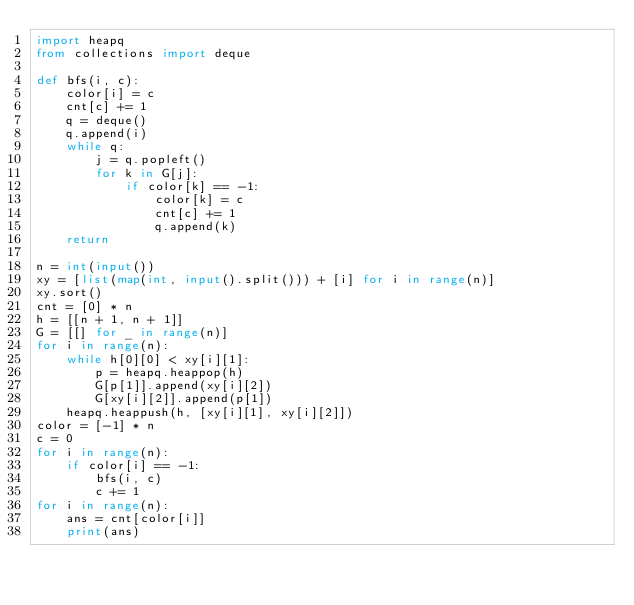Convert code to text. <code><loc_0><loc_0><loc_500><loc_500><_Python_>import heapq
from collections import deque

def bfs(i, c):
    color[i] = c
    cnt[c] += 1
    q = deque()
    q.append(i)
    while q:
        j = q.popleft()
        for k in G[j]:
            if color[k] == -1:
                color[k] = c
                cnt[c] += 1
                q.append(k)
    return

n = int(input())
xy = [list(map(int, input().split())) + [i] for i in range(n)]
xy.sort()
cnt = [0] * n
h = [[n + 1, n + 1]]
G = [[] for _ in range(n)]
for i in range(n):
    while h[0][0] < xy[i][1]:
        p = heapq.heappop(h)
        G[p[1]].append(xy[i][2])
        G[xy[i][2]].append(p[1])
    heapq.heappush(h, [xy[i][1], xy[i][2]])
color = [-1] * n
c = 0
for i in range(n):
    if color[i] == -1:
        bfs(i, c)
        c += 1
for i in range(n):
    ans = cnt[color[i]]
    print(ans)</code> 